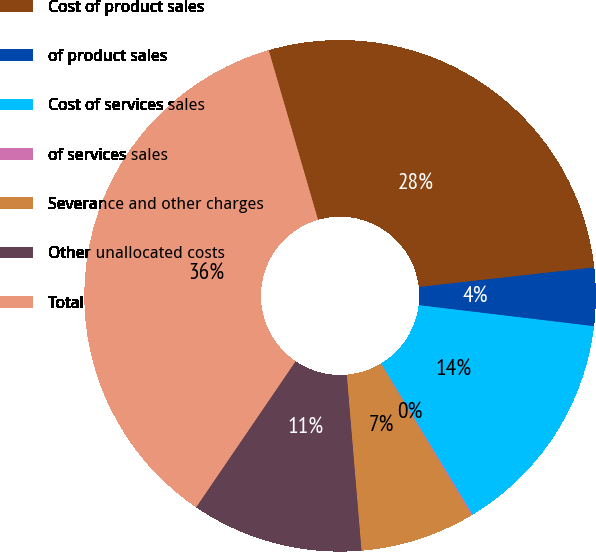<chart> <loc_0><loc_0><loc_500><loc_500><pie_chart><fcel>Cost of product sales<fcel>of product sales<fcel>Cost of services sales<fcel>of services sales<fcel>Severance and other charges<fcel>Other unallocated costs<fcel>Total<nl><fcel>27.74%<fcel>3.67%<fcel>14.44%<fcel>0.07%<fcel>7.26%<fcel>10.85%<fcel>35.98%<nl></chart> 